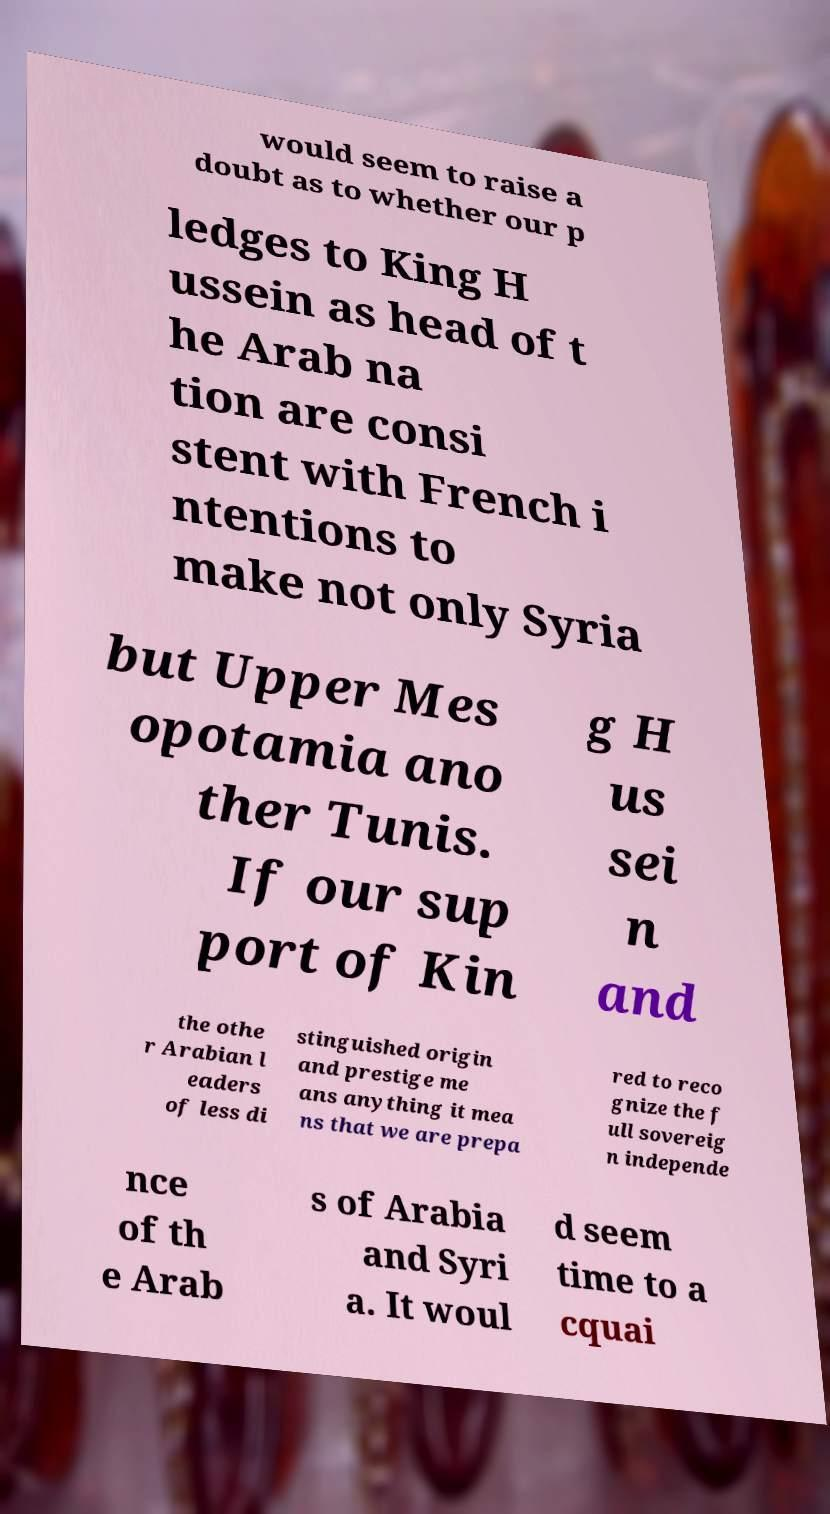Could you assist in decoding the text presented in this image and type it out clearly? would seem to raise a doubt as to whether our p ledges to King H ussein as head of t he Arab na tion are consi stent with French i ntentions to make not only Syria but Upper Mes opotamia ano ther Tunis. If our sup port of Kin g H us sei n and the othe r Arabian l eaders of less di stinguished origin and prestige me ans anything it mea ns that we are prepa red to reco gnize the f ull sovereig n independe nce of th e Arab s of Arabia and Syri a. It woul d seem time to a cquai 